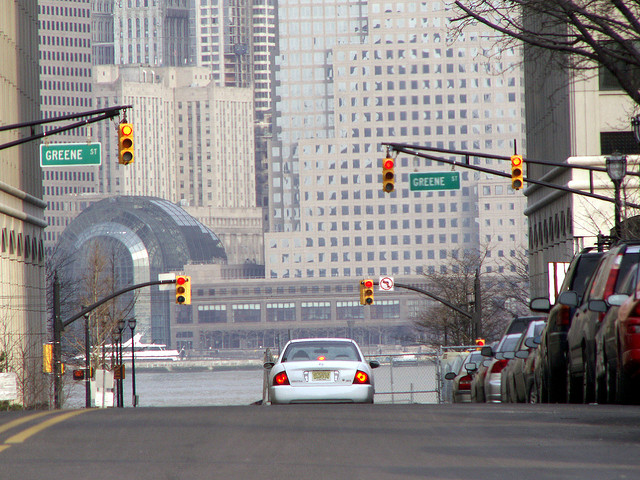Read all the text in this image. GREENE GREENE 